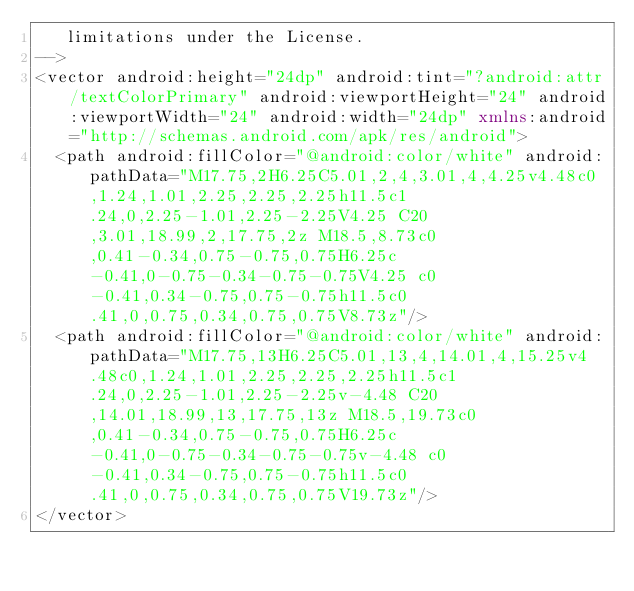<code> <loc_0><loc_0><loc_500><loc_500><_XML_>   limitations under the License.
-->
<vector android:height="24dp" android:tint="?android:attr/textColorPrimary" android:viewportHeight="24" android:viewportWidth="24" android:width="24dp" xmlns:android="http://schemas.android.com/apk/res/android">
  <path android:fillColor="@android:color/white" android:pathData="M17.75,2H6.25C5.01,2,4,3.01,4,4.25v4.48c0,1.24,1.01,2.25,2.25,2.25h11.5c1.24,0,2.25-1.01,2.25-2.25V4.25 C20,3.01,18.99,2,17.75,2z M18.5,8.73c0,0.41-0.34,0.75-0.75,0.75H6.25c-0.41,0-0.75-0.34-0.75-0.75V4.25 c0-0.41,0.34-0.75,0.75-0.75h11.5c0.41,0,0.75,0.34,0.75,0.75V8.73z"/>
  <path android:fillColor="@android:color/white" android:pathData="M17.75,13H6.25C5.01,13,4,14.01,4,15.25v4.48c0,1.24,1.01,2.25,2.25,2.25h11.5c1.24,0,2.25-1.01,2.25-2.25v-4.48 C20,14.01,18.99,13,17.75,13z M18.5,19.73c0,0.41-0.34,0.75-0.75,0.75H6.25c-0.41,0-0.75-0.34-0.75-0.75v-4.48 c0-0.41,0.34-0.75,0.75-0.75h11.5c0.41,0,0.75,0.34,0.75,0.75V19.73z"/>
</vector></code> 